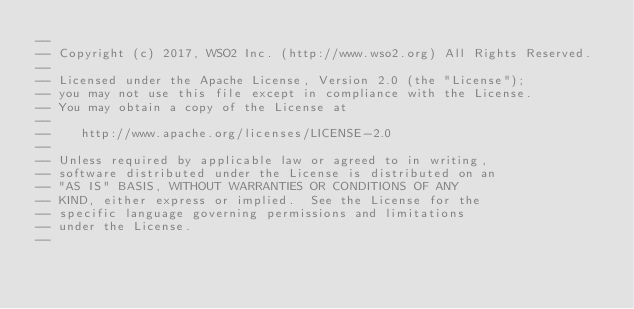Convert code to text. <code><loc_0><loc_0><loc_500><loc_500><_SQL_>--
-- Copyright (c) 2017, WSO2 Inc. (http://www.wso2.org) All Rights Reserved.
--
-- Licensed under the Apache License, Version 2.0 (the "License");
-- you may not use this file except in compliance with the License.
-- You may obtain a copy of the License at
--
--    http://www.apache.org/licenses/LICENSE-2.0
--
-- Unless required by applicable law or agreed to in writing,
-- software distributed under the License is distributed on an
-- "AS IS" BASIS, WITHOUT WARRANTIES OR CONDITIONS OF ANY
-- KIND, either express or implied.  See the License for the
-- specific language governing permissions and limitations
-- under the License.
--</code> 